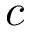<formula> <loc_0><loc_0><loc_500><loc_500>c</formula> 